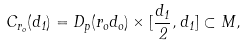Convert formula to latex. <formula><loc_0><loc_0><loc_500><loc_500>C _ { r _ { o } } ( d _ { 1 } ) = D _ { p } ( r _ { o } d _ { o } ) \times [ \frac { d _ { 1 } } { 2 } , d _ { 1 } ] \subset { M } ,</formula> 